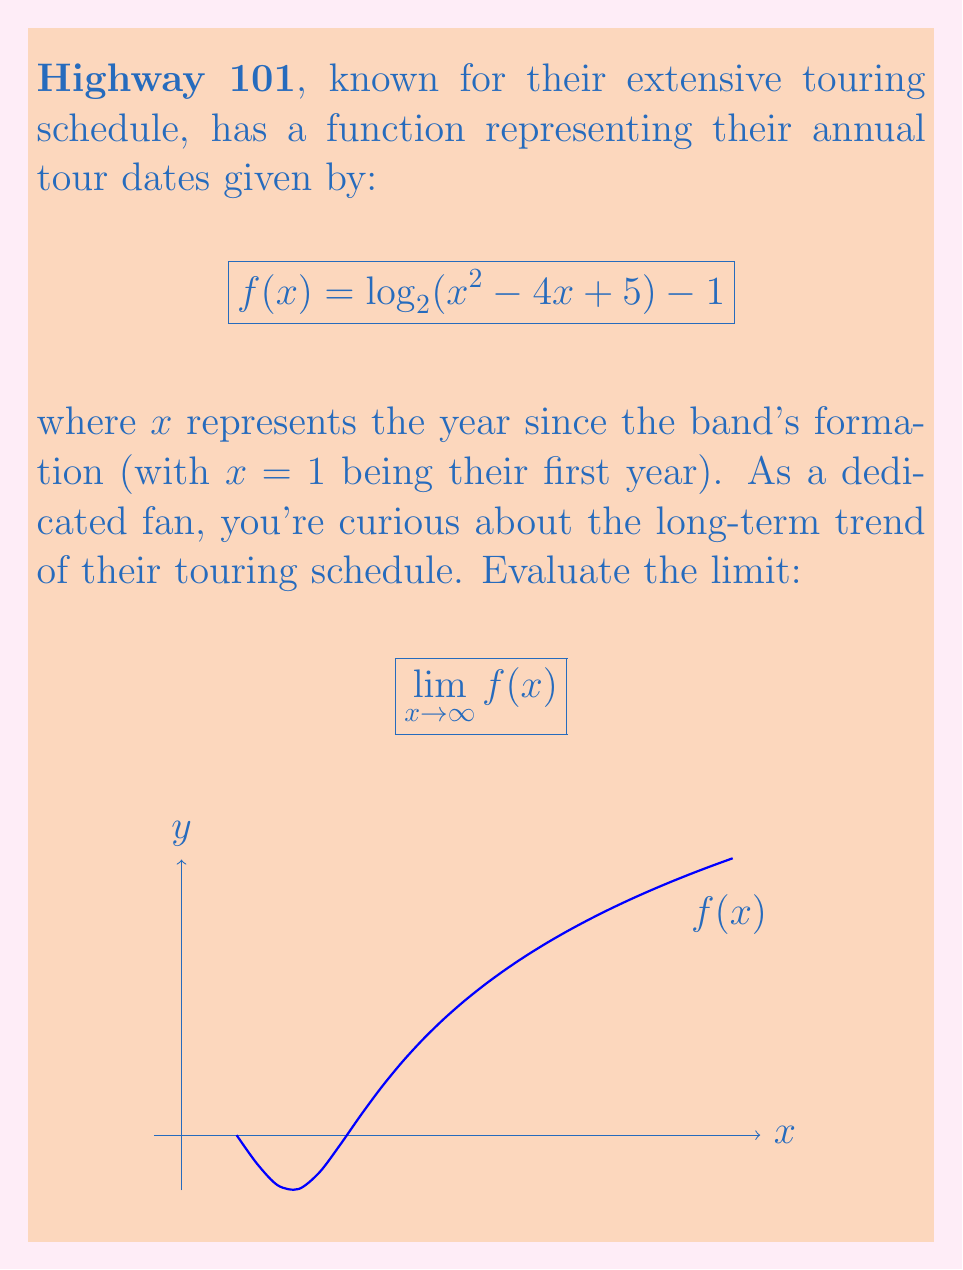Provide a solution to this math problem. Let's approach this step-by-step:

1) First, let's consider the behavior of the function inside the logarithm as x approaches infinity:
   $$\lim_{x \to \infty} (x^2 - 4x + 5)$$

2) As x gets very large, the $x^2$ term dominates. The -4x and +5 become negligible in comparison:
   $$\lim_{x \to \infty} (x^2 - 4x + 5) = \lim_{x \to \infty} x^2$$

3) Now our limit becomes:
   $$\lim_{x \to \infty} [\log_2(x^2) - 1]$$

4) Using the logarithm property $\log_a(x^n) = n\log_a(x)$, we can rewrite this as:
   $$\lim_{x \to \infty} [2\log_2(x) - 1]$$

5) As x approaches infinity, $\log_2(x)$ also approaches infinity, but at a slower rate.

6) Therefore, $2\log_2(x)$ approaches infinity as x approaches infinity.

7) The -1 term becomes negligible compared to $2\log_2(x)$ as x approaches infinity.

8) Thus, the limit of the entire expression approaches infinity.
Answer: $\infty$ 